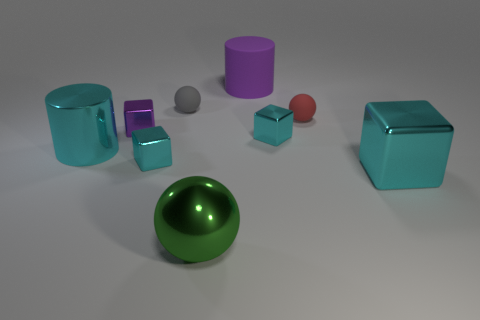What emotions or mood does the color palette of the image evoke? The image's color palette, with cool tones of blue and cyan mixed with touches of red, purple, and green, evokes a modern and clean mood. It feels calm and tranquil, with the metallic sheen adding a sense of sophistication. 